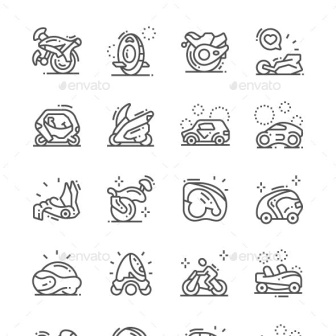Describe the following image. The image showcases a collection of 16 black and white line icons, each symbolizing a distinct mode of transportation. These icons are orderly arranged in a 4x4 grid. Starting from the top left, the first icon depicts a motorcycle, followed by a unicycle, a motorcycle helmet, and finally, a racecar. The second row includes a futuristic enclosed vehicle, a jet ski, a car, and another futuristic vehicle. Next, the third row begins with a person on a sled, then shows a snowmobile, a car with a tire on top, and a small compact car. The fourth and final row begins with a covered vehicle, followed by a submersible, a motorcyclist, and ends with a convertible sports car. These icons are simple yet articulated, providing clear visual representation of various transportation means. The monochromatic black and white palette adds a classic and timeless aesthetic to the illustration. 